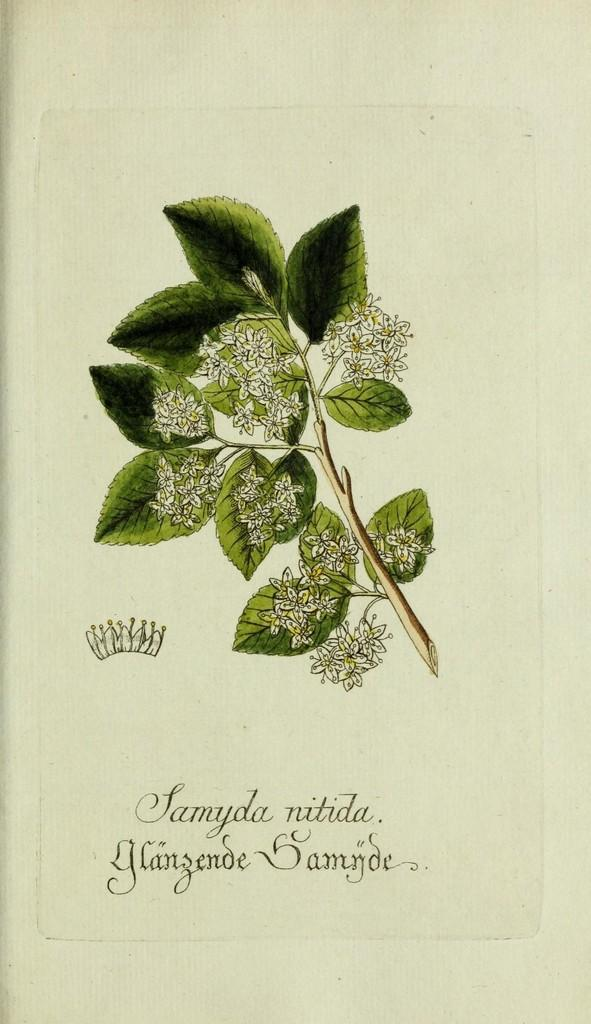What is depicted in the image? The image contains a sketch of flowers and leaves. Can you describe the text at the bottom of the image? Unfortunately, the provided facts do not give any information about the text at the bottom of the image. What type of vegetation is included in the sketch? The sketch includes flowers and leaves. What position does the dog hold in the family, as depicted in the image? There is no dog present in the image; it only contains a sketch of flowers and leaves. 